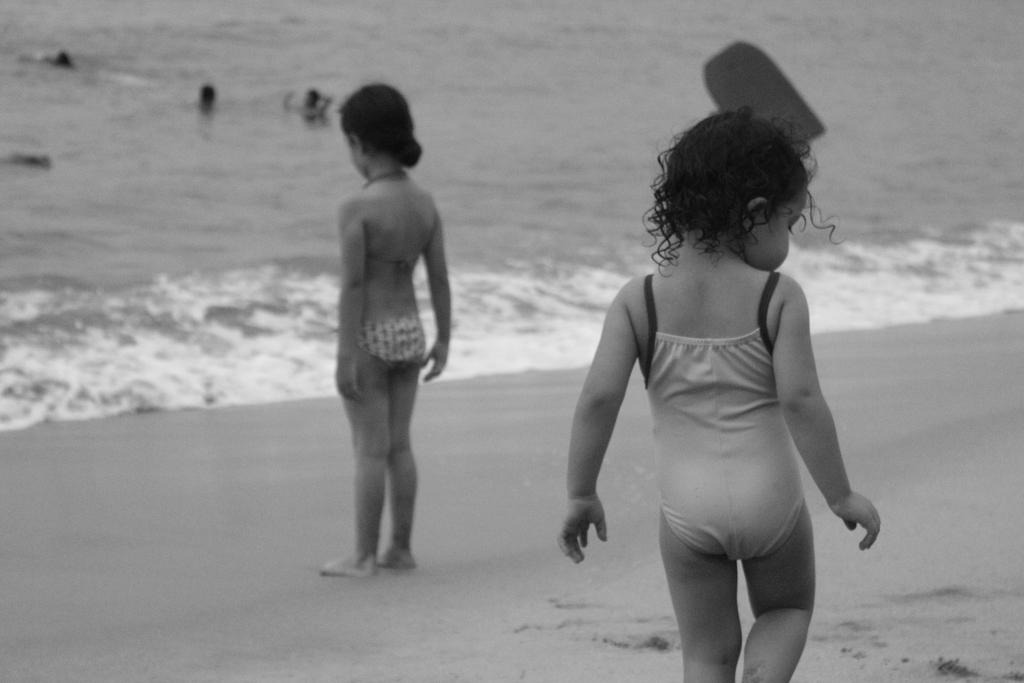What is the color scheme of the image? The image is black and white. What can be seen in the background of the image? There are two children standing on the seashore. What is happening in the water body in the image? There are people in a water body. What type of notebook is being used by the fish in the image? There are no fish or notebooks present in the image. 